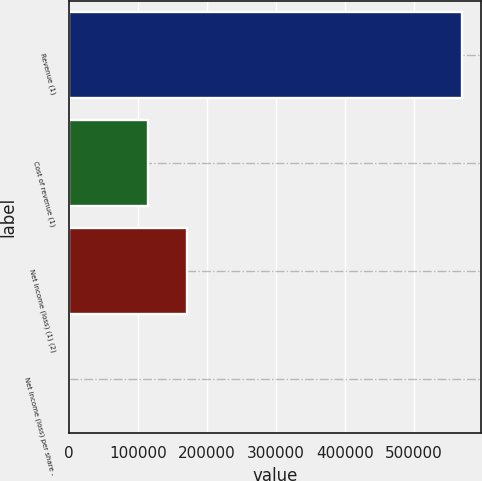<chart> <loc_0><loc_0><loc_500><loc_500><bar_chart><fcel>Revenue (1)<fcel>Cost of revenue (1)<fcel>Net income (loss) (1) (2)<fcel>Net income (loss) per share -<nl><fcel>569850<fcel>113970<fcel>170955<fcel>0.35<nl></chart> 